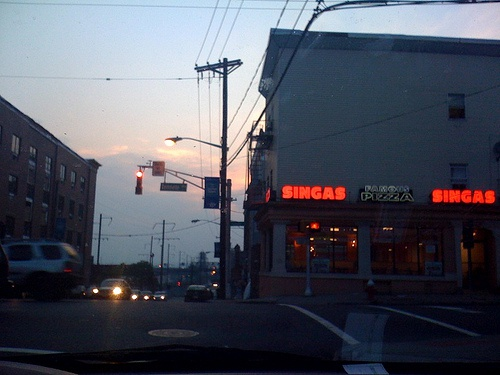Describe the objects in this image and their specific colors. I can see car in darkgray, black, navy, gray, and maroon tones, car in darkgray, black, maroon, gray, and ivory tones, car in black, maroon, brown, and darkgray tones, car in darkgray, black, gray, and darkblue tones, and traffic light in darkgray, black, maroon, white, and brown tones in this image. 